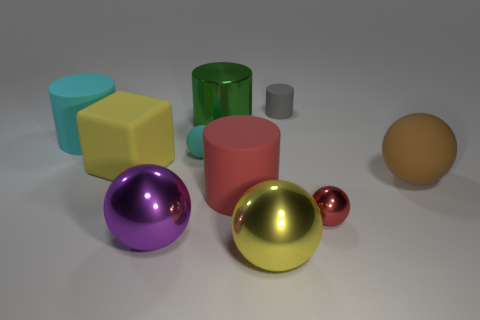There is a large object that is the same color as the big matte cube; what is its shape?
Ensure brevity in your answer.  Sphere. What number of large metallic things have the same shape as the tiny cyan object?
Your response must be concise. 2. The sphere that is behind the matte ball to the right of the small red sphere is made of what material?
Provide a succinct answer. Rubber. Are there an equal number of big purple shiny things and small blue matte spheres?
Offer a terse response. No. There is a cylinder in front of the brown object; what size is it?
Your answer should be very brief. Large. What number of gray objects are either blocks or large matte balls?
Keep it short and to the point. 0. Are there any other things that are the same material as the big green object?
Offer a very short reply. Yes. There is a tiny red object that is the same shape as the big purple shiny thing; what material is it?
Your response must be concise. Metal. Are there the same number of gray things behind the big brown object and purple spheres?
Your answer should be compact. Yes. How big is the sphere that is both behind the red matte cylinder and right of the tiny gray object?
Your answer should be very brief. Large. 